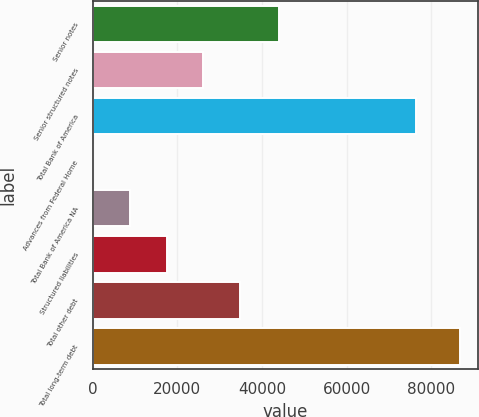Convert chart. <chart><loc_0><loc_0><loc_500><loc_500><bar_chart><fcel>Senior notes<fcel>Senior structured notes<fcel>Total Bank of America<fcel>Advances from Federal Home<fcel>Total Bank of America NA<fcel>Structured liabilities<fcel>Total other debt<fcel>Total long-term debt<nl><fcel>44011<fcel>26096.9<fcel>76359<fcel>116<fcel>8776.3<fcel>17436.6<fcel>34757.2<fcel>86719<nl></chart> 